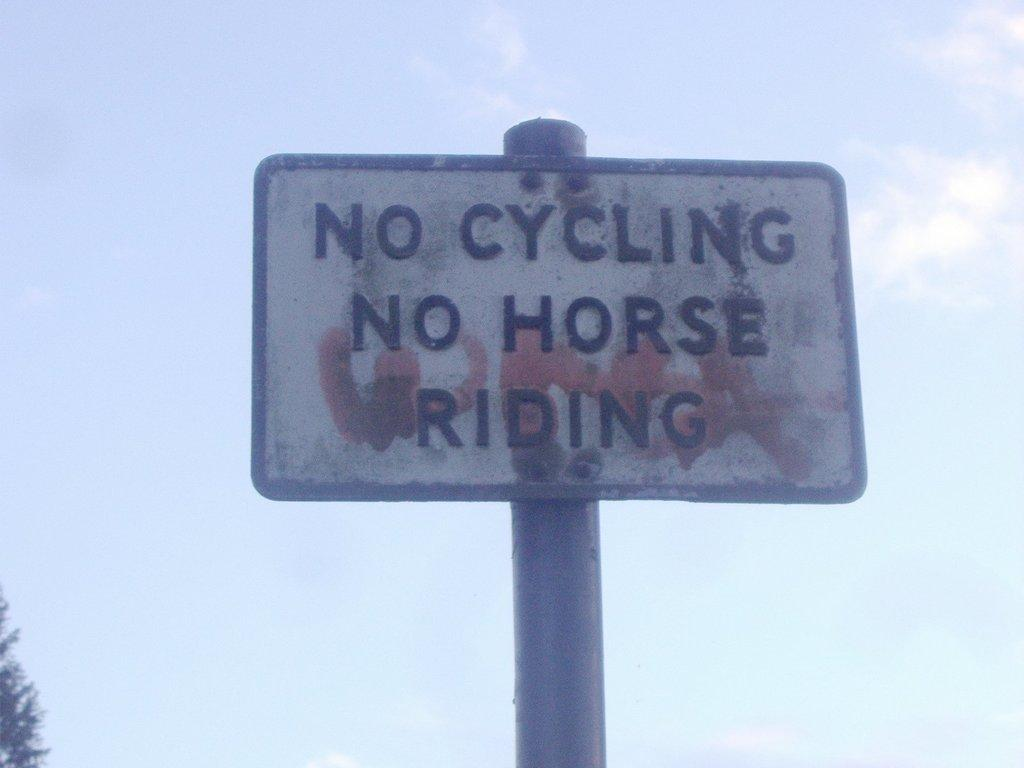<image>
Offer a succinct explanation of the picture presented. A rusted white and black sign on a pole that reads no cycling no horse riding. 